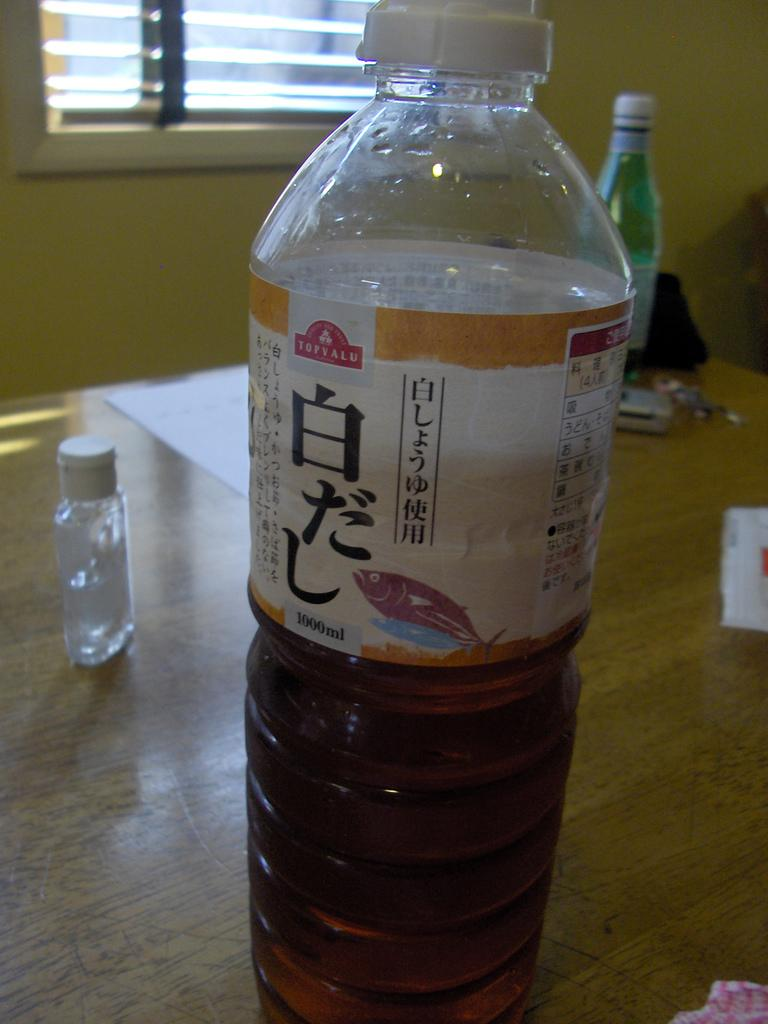<image>
Give a short and clear explanation of the subsequent image. A bottle with foreign letters and the brand Topvalu on it. 